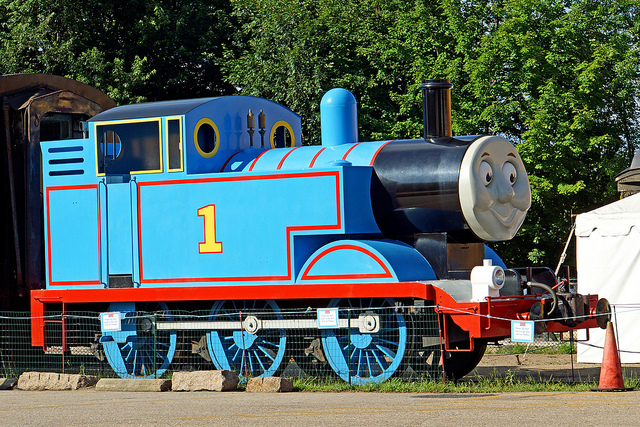Read all the text in this image. 1 